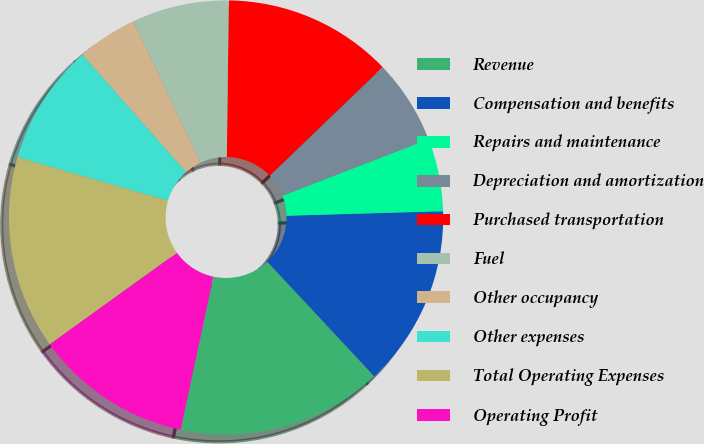Convert chart to OTSL. <chart><loc_0><loc_0><loc_500><loc_500><pie_chart><fcel>Revenue<fcel>Compensation and benefits<fcel>Repairs and maintenance<fcel>Depreciation and amortization<fcel>Purchased transportation<fcel>Fuel<fcel>Other occupancy<fcel>Other expenses<fcel>Total Operating Expenses<fcel>Operating Profit<nl><fcel>15.31%<fcel>13.51%<fcel>5.41%<fcel>6.31%<fcel>12.61%<fcel>7.21%<fcel>4.5%<fcel>9.01%<fcel>14.41%<fcel>11.71%<nl></chart> 